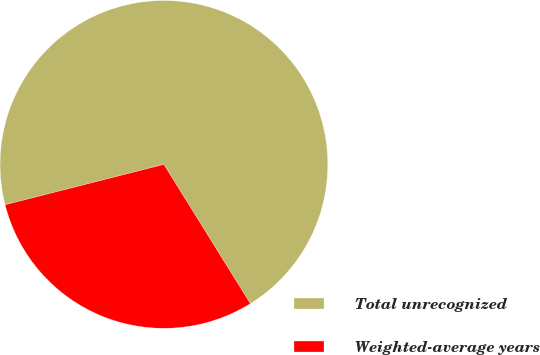Convert chart. <chart><loc_0><loc_0><loc_500><loc_500><pie_chart><fcel>Total unrecognized<fcel>Weighted-average years<nl><fcel>70.11%<fcel>29.89%<nl></chart> 